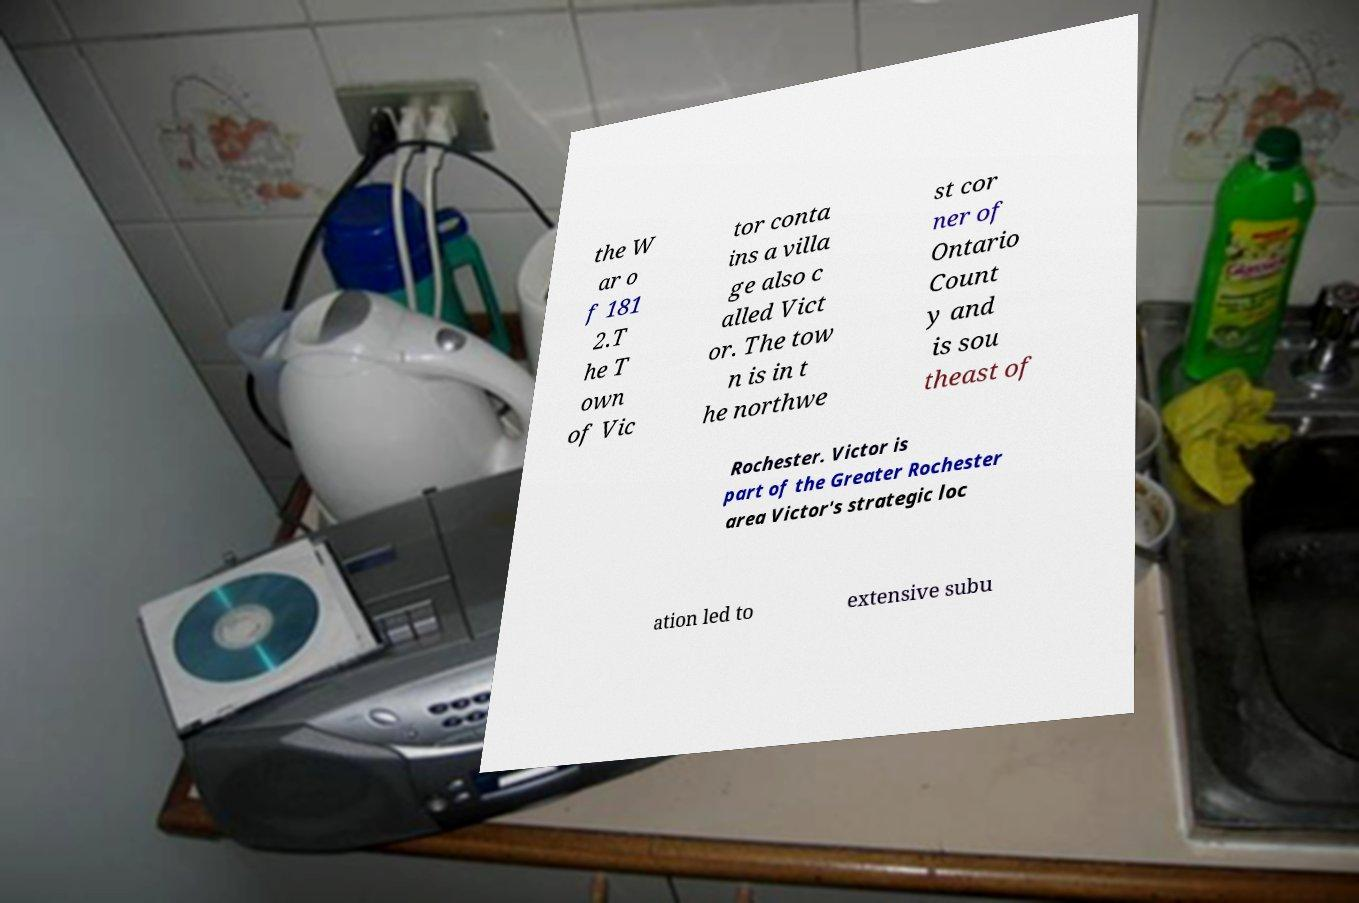Please read and relay the text visible in this image. What does it say? the W ar o f 181 2.T he T own of Vic tor conta ins a villa ge also c alled Vict or. The tow n is in t he northwe st cor ner of Ontario Count y and is sou theast of Rochester. Victor is part of the Greater Rochester area Victor's strategic loc ation led to extensive subu 